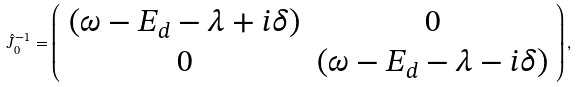Convert formula to latex. <formula><loc_0><loc_0><loc_500><loc_500>\hat { J } _ { 0 } ^ { - 1 } = \left ( \begin{array} { c c } ( \omega - E _ { d } - \lambda + i \delta ) & 0 \\ 0 & ( \omega - E _ { d } - \lambda - i \delta ) \end{array} \right ) ,</formula> 